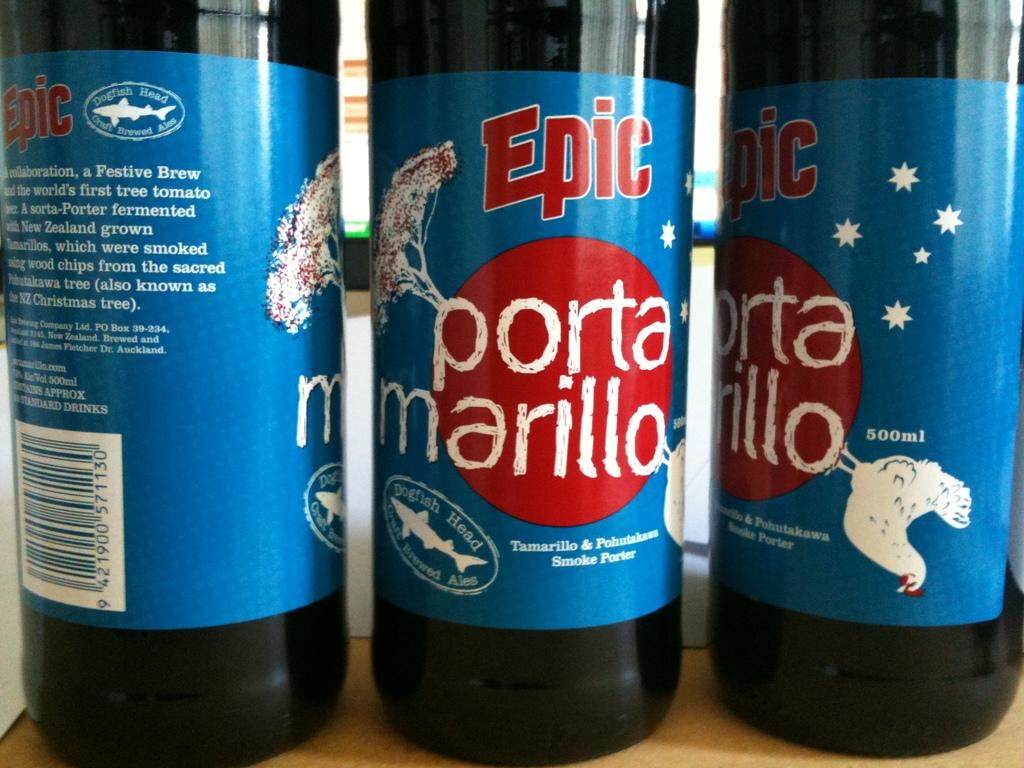Provide a one-sentence caption for the provided image. Three Epic bottles stand upright next to one another. 